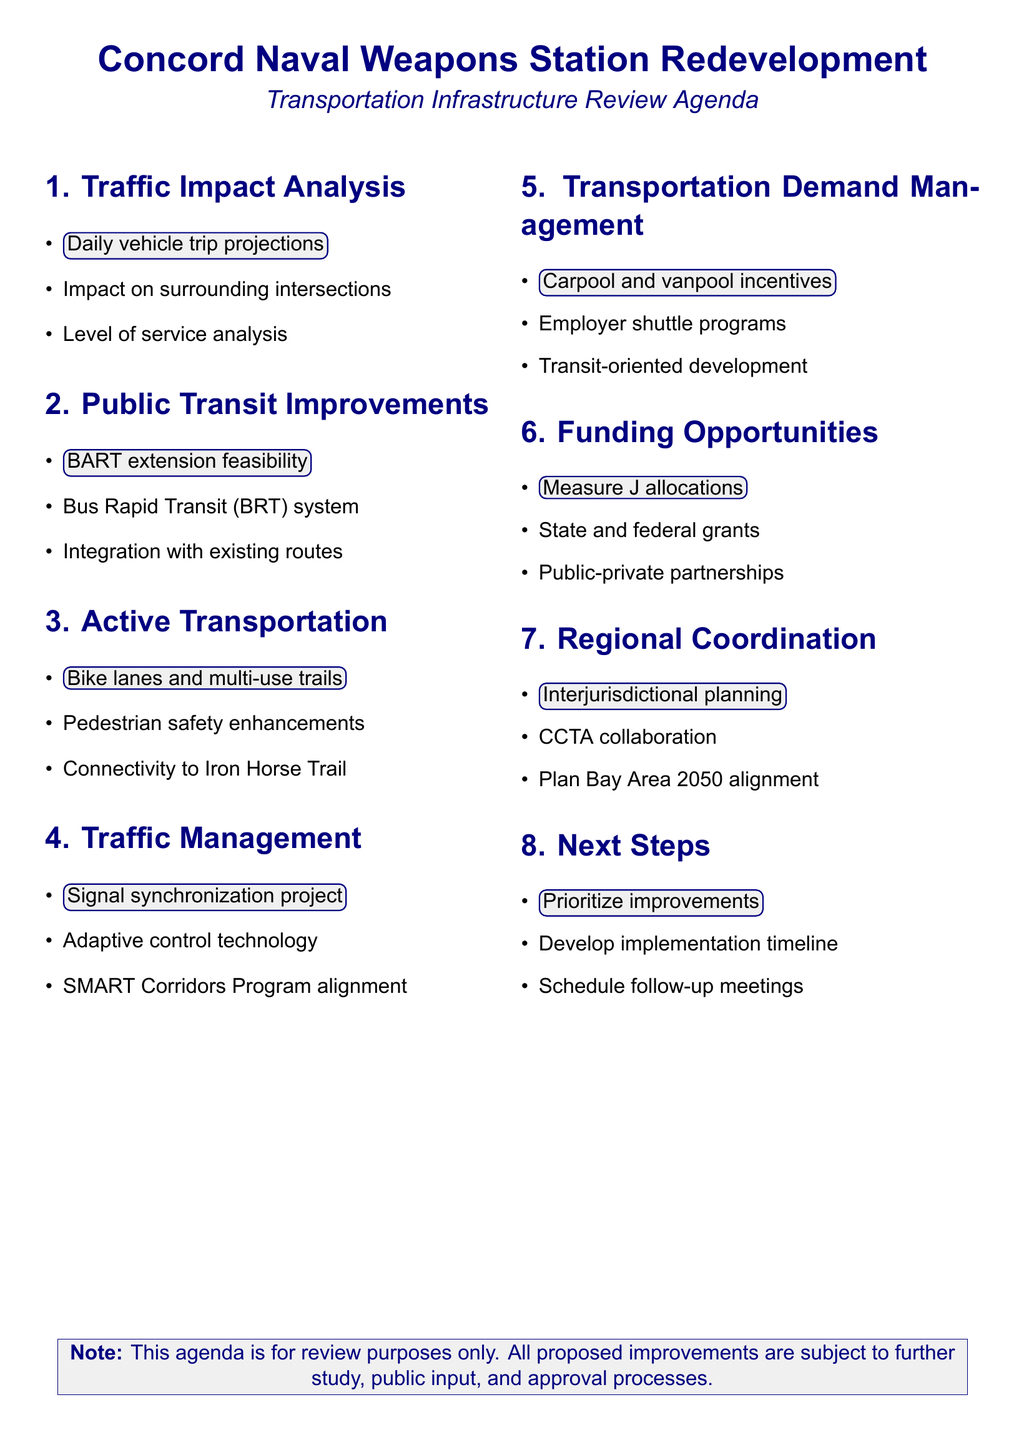What is the title of the traffic impact analysis report? The title is listed in the document under the Traffic Impact Analysis section.
Answer: Traffic Impact Analysis Report by Fehr & Peers Which two roadways are part of the traffic signal synchronization project? The document lists specific corridors included in the signal synchronization project.
Answer: Clayton Road, Willow Pass Road What is one proposed measure to reduce single-occupancy vehicle trips? The document provides specific strategies under the Transportation Demand Management section.
Answer: Carpool and vanpool incentives How many miles of new bike lanes and trails are proposed? This information can be found in the Bicycle and Pedestrian Infrastructure Plan section.
Answer: Miles of new bike lanes and trails (not specified) What are the ridership projections associated with the BART extension? The document summarizes key points related to the BART extension feasibility study.
Answer: Ridership projections (not specified) What is the primary goal of the interjurisdictional coordination plan? The document states the purpose of the coordination plan.
Answer: Framework for collaboration between Concord, neighboring cities, and regional transportation agencies What is one funding source mentioned for transportation improvements? The document provides an overview of potential funding sources.
Answer: Measure J transportation sales tax allocations What technology will be used in the signal synchronization project? The document lists features for improving traffic flow under the Traffic Management section.
Answer: Adaptive signal control technology 